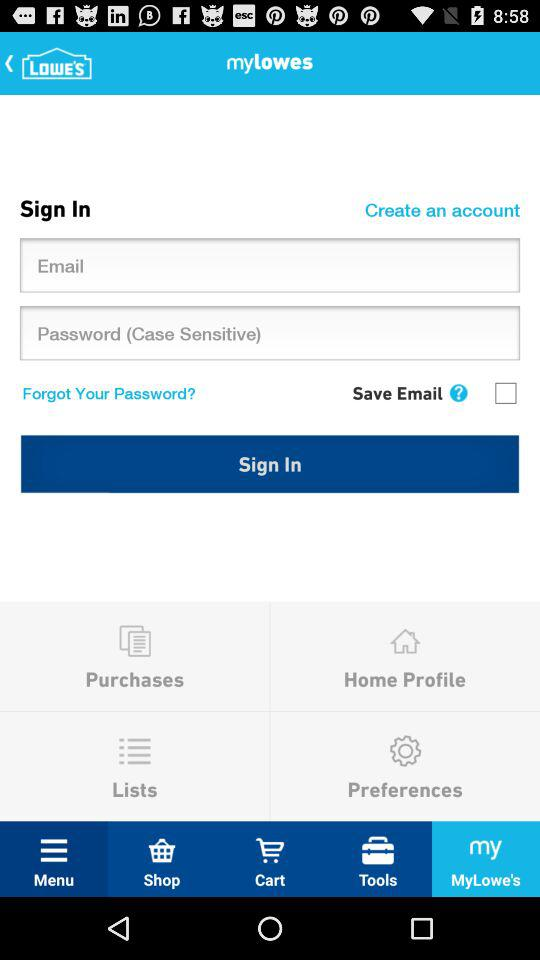Which option is selected in the taskbar? The selected option is "MyLowe's". 